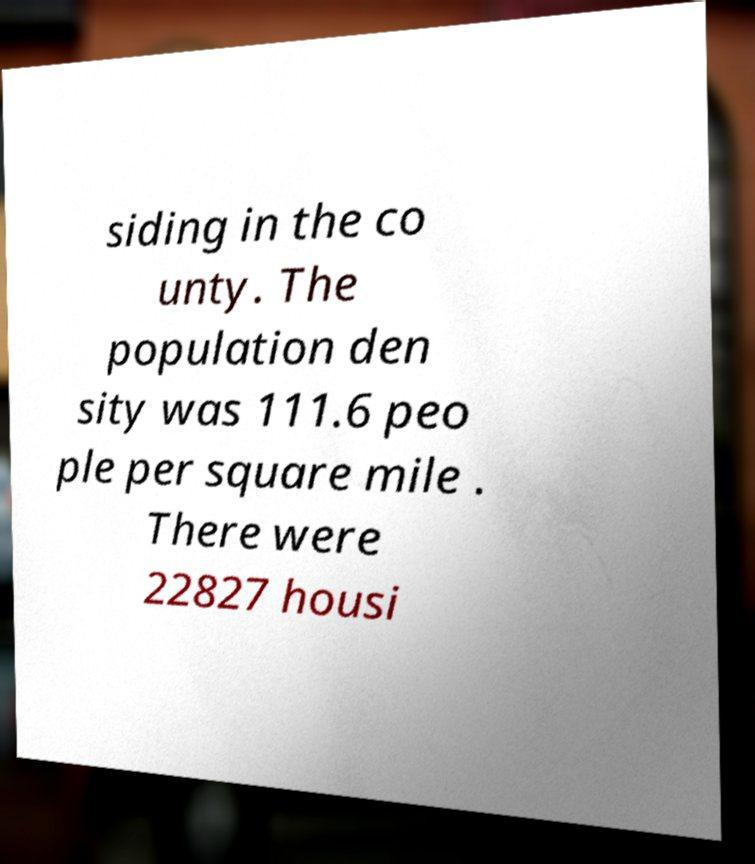Please read and relay the text visible in this image. What does it say? siding in the co unty. The population den sity was 111.6 peo ple per square mile . There were 22827 housi 